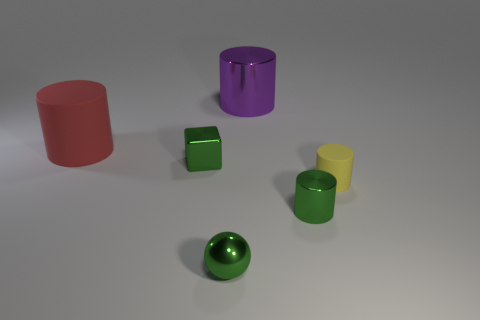What is the material of the big thing behind the rubber cylinder that is on the left side of the tiny metal cylinder?
Your answer should be compact. Metal. Is the size of the green metal cylinder the same as the purple thing?
Keep it short and to the point. No. What number of things are either small metal things right of the green metallic sphere or blue metal objects?
Make the answer very short. 1. There is a metal thing that is behind the tiny metallic object that is behind the small green cylinder; what is its shape?
Provide a succinct answer. Cylinder. There is a green sphere; does it have the same size as the green shiny object that is behind the tiny yellow cylinder?
Keep it short and to the point. Yes. What material is the cylinder that is behind the big red object?
Make the answer very short. Metal. What number of things are both left of the yellow object and to the right of the metal block?
Offer a terse response. 3. What is the material of the sphere that is the same size as the block?
Make the answer very short. Metal. There is a rubber cylinder that is behind the tiny yellow thing; is its size the same as the yellow matte object that is in front of the large red cylinder?
Your answer should be very brief. No. There is a large rubber thing; are there any shiny cylinders to the left of it?
Offer a terse response. No. 